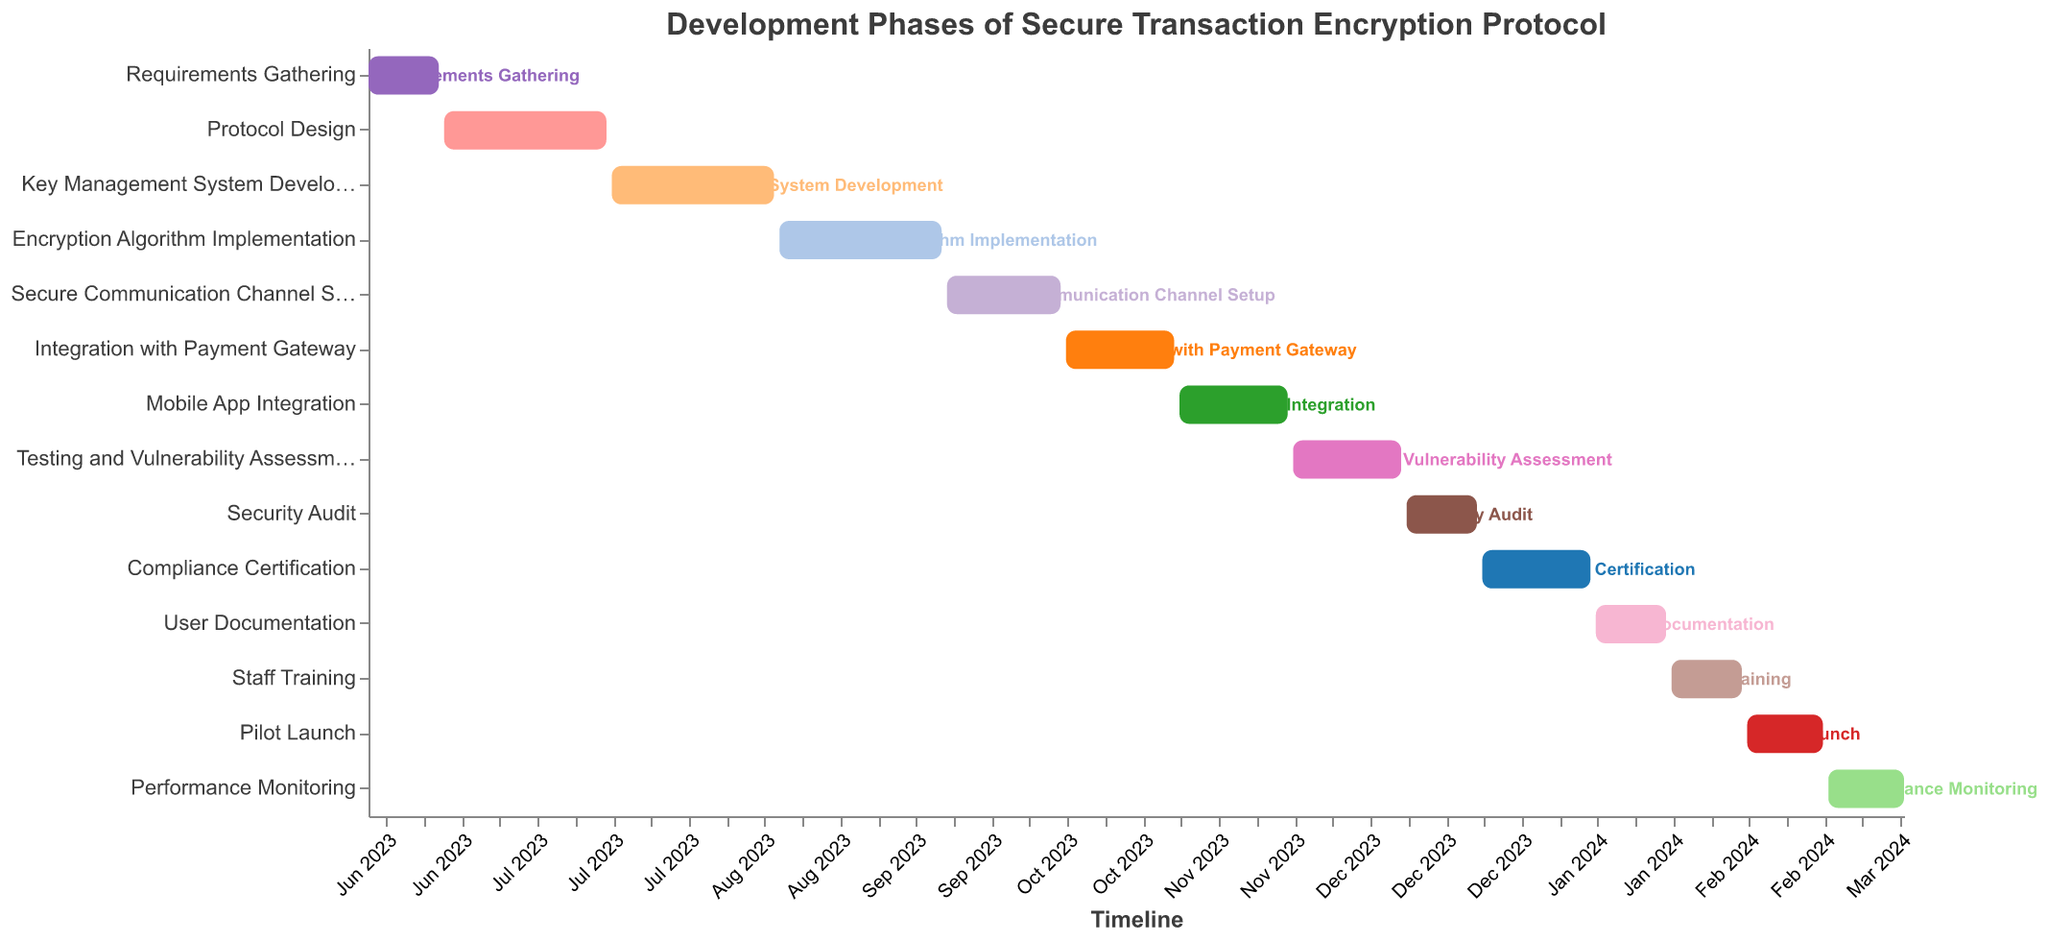What's the duration of the "Protocol Design" phase? Look at the bar labeled "Protocol Design" and observe the duration mentioned.
Answer: 31 days When does the "Integration with Payment Gateway" start and end? Examine the bar labeled "Integration with Payment Gateway" for its start and end dates.
Answer: Oct 8, 2023 to Oct 28, 2023 Which phase lasts the longest? Compare the lengths of all bars to see which is the longest.
Answer: Protocol Design, Key Management System Development, and Encryption Algorithm Implementation How many tasks last exactly 21 days? Count the bars with a duration labeled as 21 days.
Answer: 5 tasks What's the total time span from the start of "Requirements Gathering" to the end of "Performance Monitoring"? Note the start date of "Requirements Gathering" and the end date of "Performance Monitoring", then calculate the difference.
Answer: Jun 1, 2023 to Mar 11, 2024 Which tasks end in December 2023? Look at all tasks and identify those with end dates within December 2023.
Answer: Security Audit What is the duration of the "Pilot Launch" phase? Observe the bar labeled "Pilot Launch" and note the duration mentioned.
Answer: 15 days Between "Testing and Vulnerability Assessment" and "Security Audit," which task has a shorter duration? Compare the durations of these two tasks using their respective bars.
Answer: Security Audit Which phase begins immediately after "Protocol Design"? Identify the task that starts right after the end date of "Protocol Design."
Answer: Key Management System Development How long is the gap between the end of the "Secure Communication Channel Setup" and the start of "Mobile App Integration"? Note the end date of the "Secure Communication Channel Setup" and the start date of the "Mobile App Integration" and calculate the difference.
Answer: 21 days 